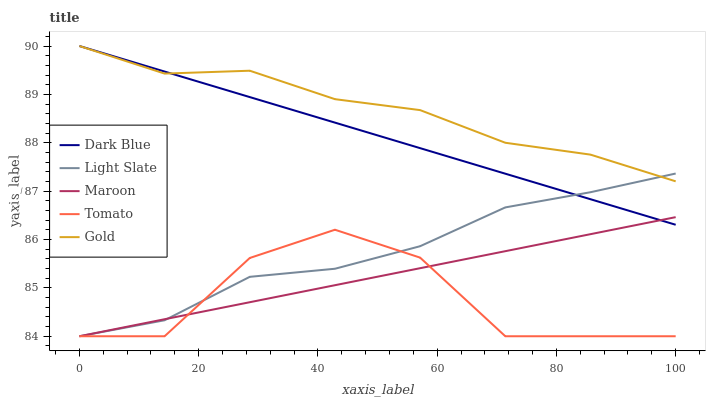Does Tomato have the minimum area under the curve?
Answer yes or no. Yes. Does Gold have the maximum area under the curve?
Answer yes or no. Yes. Does Dark Blue have the minimum area under the curve?
Answer yes or no. No. Does Dark Blue have the maximum area under the curve?
Answer yes or no. No. Is Dark Blue the smoothest?
Answer yes or no. Yes. Is Tomato the roughest?
Answer yes or no. Yes. Is Tomato the smoothest?
Answer yes or no. No. Is Dark Blue the roughest?
Answer yes or no. No. Does Light Slate have the lowest value?
Answer yes or no. Yes. Does Dark Blue have the lowest value?
Answer yes or no. No. Does Gold have the highest value?
Answer yes or no. Yes. Does Tomato have the highest value?
Answer yes or no. No. Is Maroon less than Gold?
Answer yes or no. Yes. Is Dark Blue greater than Tomato?
Answer yes or no. Yes. Does Dark Blue intersect Maroon?
Answer yes or no. Yes. Is Dark Blue less than Maroon?
Answer yes or no. No. Is Dark Blue greater than Maroon?
Answer yes or no. No. Does Maroon intersect Gold?
Answer yes or no. No. 